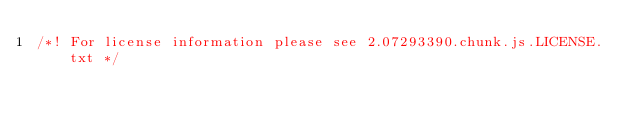<code> <loc_0><loc_0><loc_500><loc_500><_JavaScript_>/*! For license information please see 2.07293390.chunk.js.LICENSE.txt */</code> 